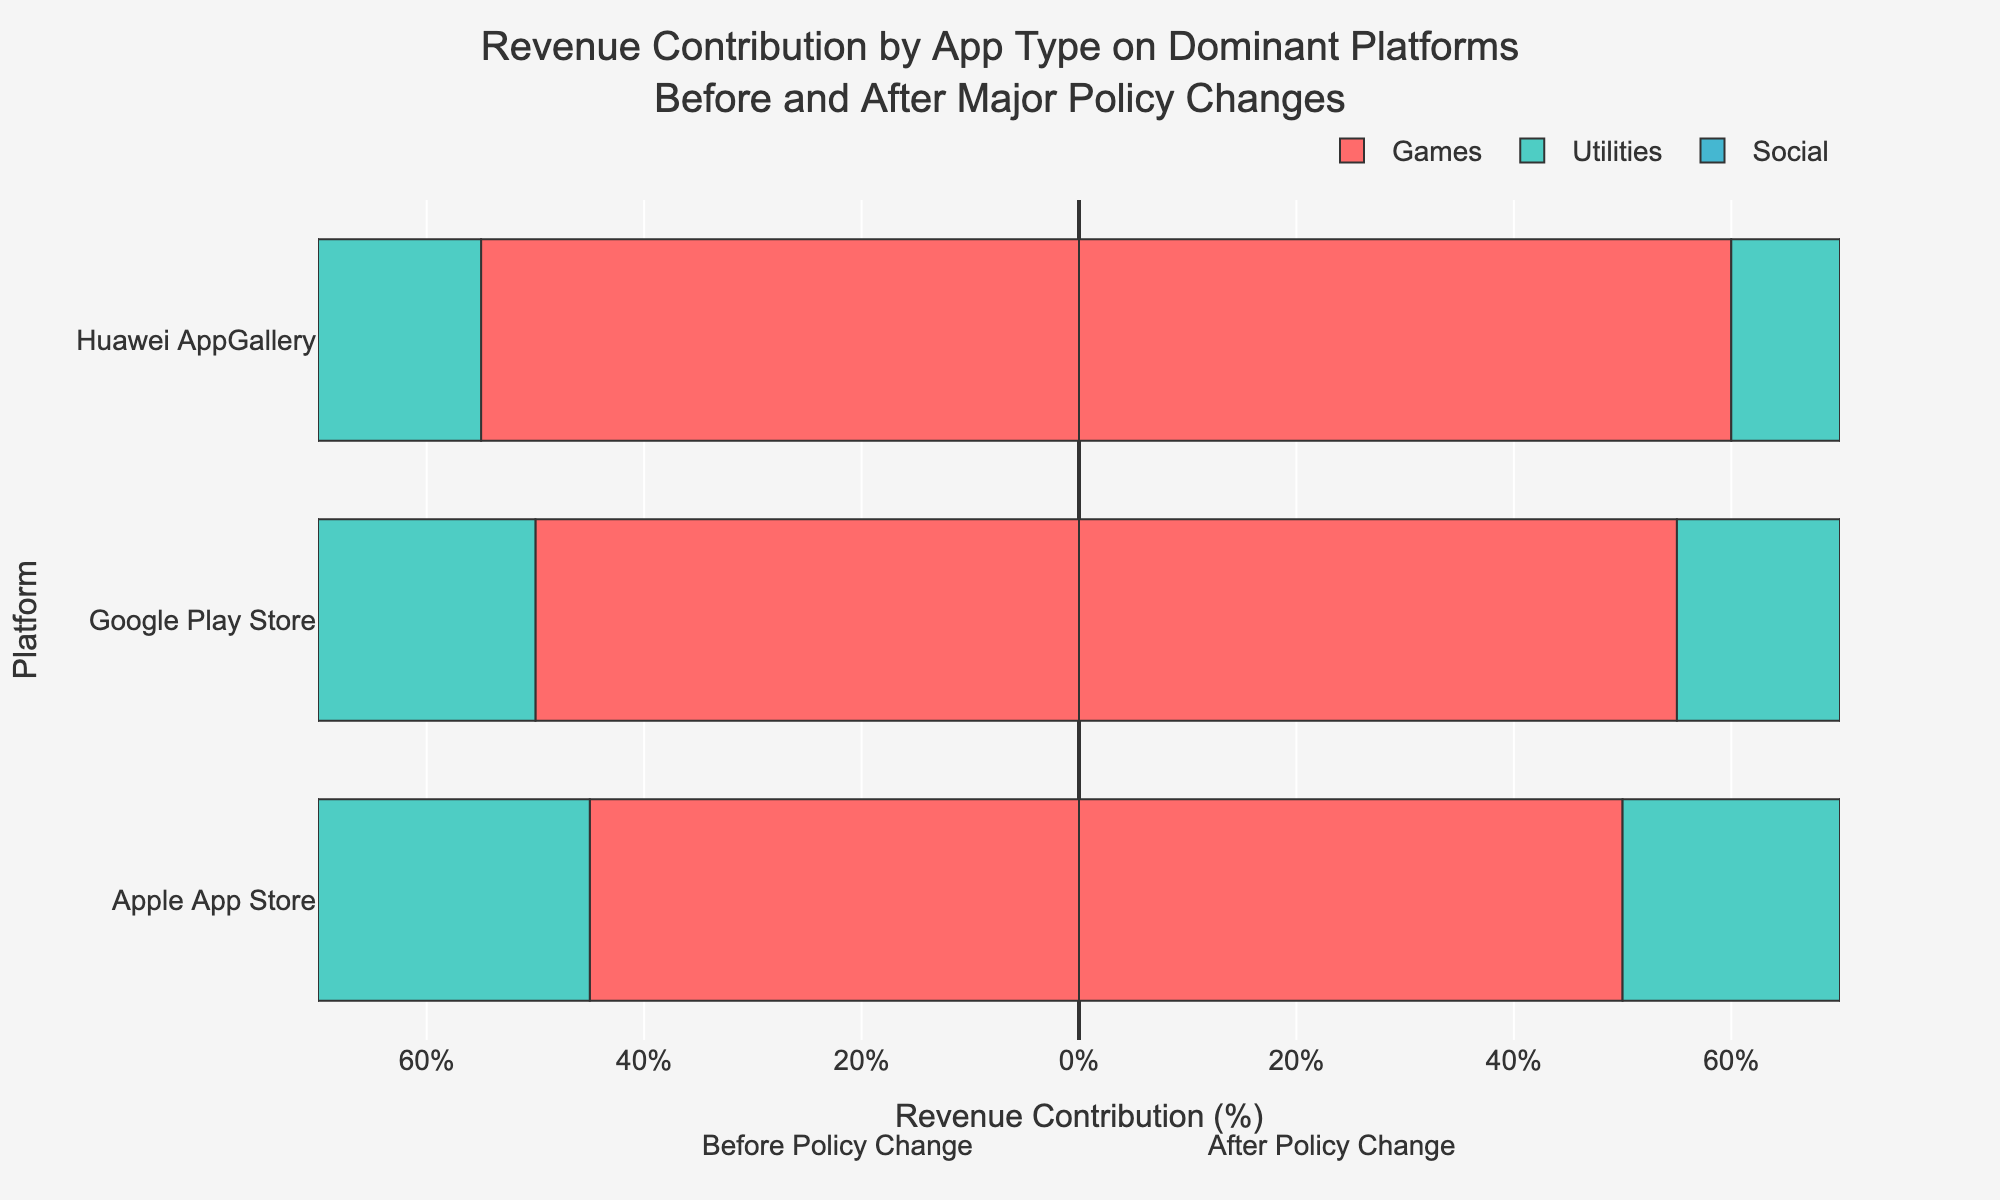What app type had the highest revenue contribution for Huawei AppGallery before the policy change? Look at the section representing Huawei AppGallery before the policy change, and observe the bars for Games, Utilities, and Social. The bar for Games is the longest.
Answer: Games Which platform saw the greatest increase in revenue contribution percentage for Utilities after the policy changes? Compare the Utilities bars before and after the policy changes for each platform. For Apple App Store, it increased from 20% to 25%. For Google Play Store, it increased from 15% to 20%. For Huawei AppGallery, it increased from 10% to 15%. The difference is 5% for each platform, so the increase is equal for all.
Answer: All platforms had the same increase What was the total revenue contribution percentage for Games across all platforms before the policy change? Sum the percentages for Games before the policy change for all platforms. Apple App Store: 50%, Google Play Store: 55%, Huawei AppGallery: 60%. 50 + 55 + 60 = 165%.
Answer: 165% Did any platform see a decrease in revenue contribution percentage for Games after the policy changes? Compare the Games bars before and after the policy changes for each platform. Apple App Store: 50% to 45%, Google Play Store: 55% to 50%, Huawei AppGallery: 60% to 55%. Each platform saw a decrease.
Answer: Yes, all platforms How did the revenue contribution for Social apps on the Apple App Store change after the policy change? Look at the Social bar for Apple App Store before and after the policy change. Both bars have the same length, indicating no change.
Answer: No change What is the total revenue contribution percentage for Utilities across all platforms after the policy changes? Sum the percentages for Utilities after the policy change for all platforms. Apple App Store: 25%, Google Play Store: 20%, Huawei AppGallery: 15%. 25 + 20 + 15 = 60%.
Answer: 60% Which app type has the most consistent revenue contribution across all platforms and policy periods? Observe the bars for each app type across all platforms and periods. Social apps have a revenue contribution of 30% consistently across all platforms and both periods.
Answer: Social Comparing Utilities revenue contribution before the policy changes, which platform had the lowest percentage? Look at the Utilities bars before the policy changes for all platforms. Huawei AppGallery's bar is the shortest with 10%.
Answer: Huawei AppGallery What is the average revenue contribution percentage for Social apps on Google Play Store across both policy periods? Calculate the average from the given percentages. Before policy change: 30%, After policy change: 30%. (30 + 30) / 2 = 30%.
Answer: 30% By how much did the revenue contribution for Games on Google Play Store change after the policy change? Compare the Games bars for Google Play Store before and after the policy change. It went from 55% to 50%, a decrease of 5%.
Answer: Decreased by 5% 